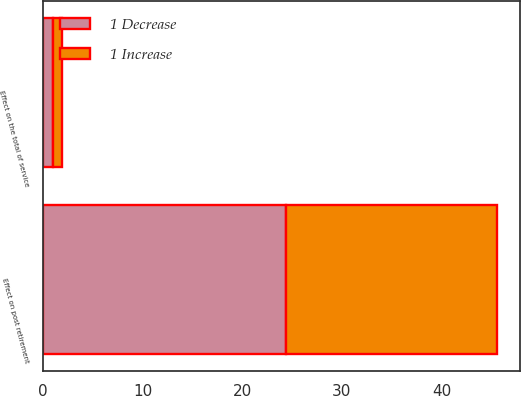Convert chart to OTSL. <chart><loc_0><loc_0><loc_500><loc_500><stacked_bar_chart><ecel><fcel>Effect on the total of service<fcel>Effect on post retirement<nl><fcel>1 Decrease<fcel>1<fcel>24.4<nl><fcel>1 Increase<fcel>0.9<fcel>21.2<nl></chart> 